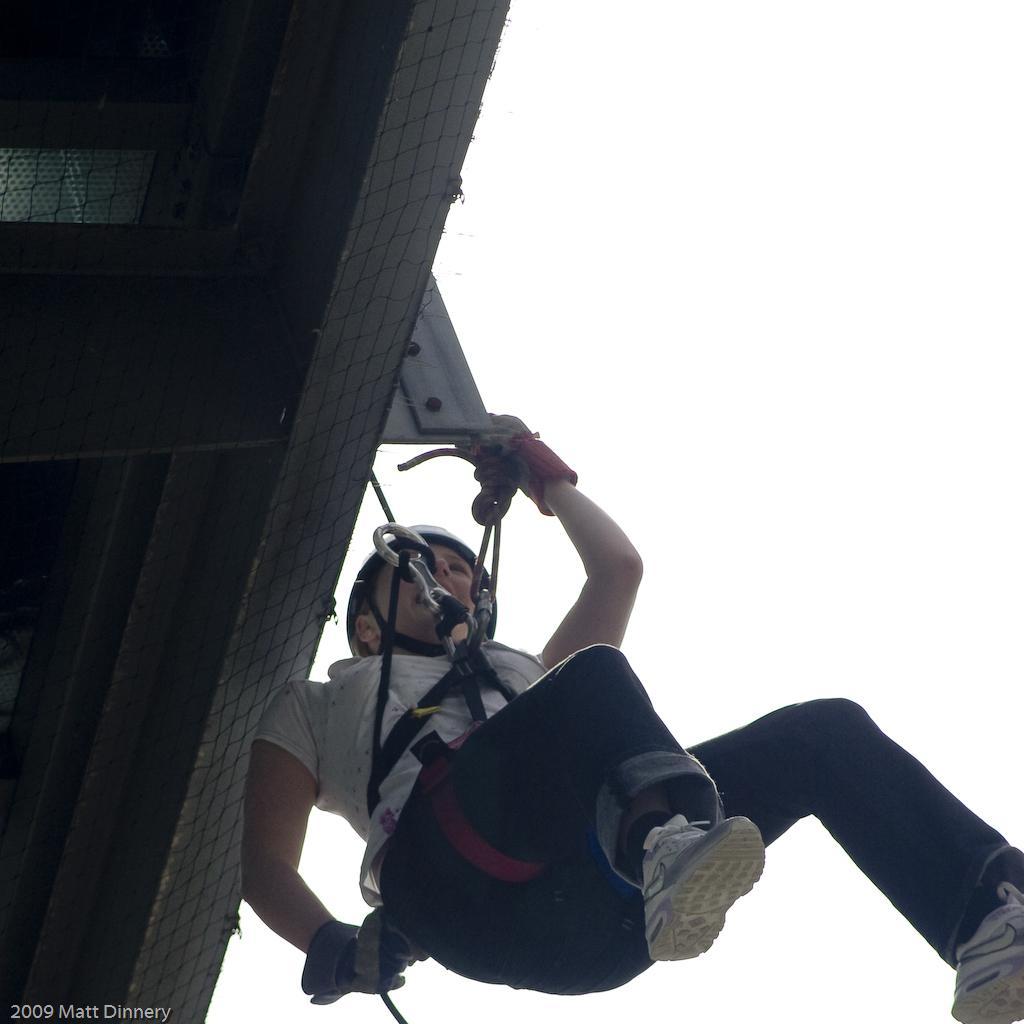How would you summarize this image in a sentence or two? This picture is clicked outside. In the center we can see a woman wearing white color t-shirt, helmet and hanging on an object with the help of the rope. In the background we can see the sky and some other objects. In the bottom left corner we can see the text and the numbers on the image. 